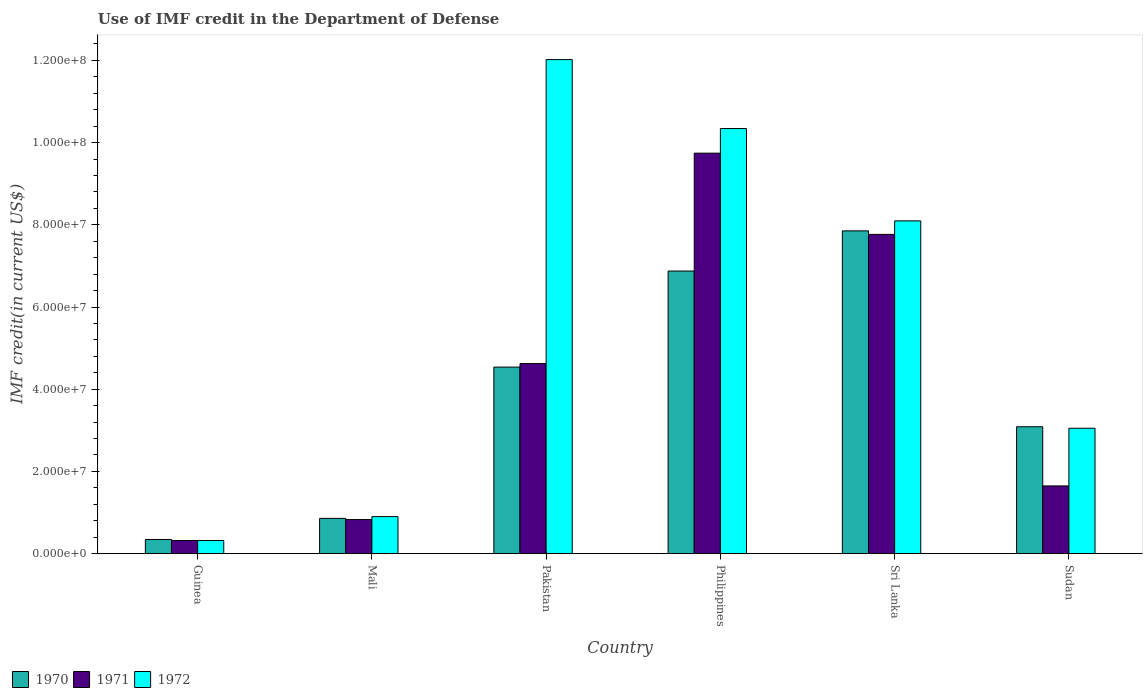How many bars are there on the 1st tick from the right?
Offer a terse response. 3. In how many cases, is the number of bars for a given country not equal to the number of legend labels?
Your answer should be very brief. 0. What is the IMF credit in the Department of Defense in 1972 in Philippines?
Your answer should be compact. 1.03e+08. Across all countries, what is the maximum IMF credit in the Department of Defense in 1971?
Your response must be concise. 9.74e+07. Across all countries, what is the minimum IMF credit in the Department of Defense in 1972?
Offer a very short reply. 3.20e+06. In which country was the IMF credit in the Department of Defense in 1971 minimum?
Provide a succinct answer. Guinea. What is the total IMF credit in the Department of Defense in 1972 in the graph?
Offer a very short reply. 3.47e+08. What is the difference between the IMF credit in the Department of Defense in 1971 in Sri Lanka and that in Sudan?
Offer a terse response. 6.12e+07. What is the difference between the IMF credit in the Department of Defense in 1972 in Sudan and the IMF credit in the Department of Defense in 1971 in Guinea?
Provide a short and direct response. 2.73e+07. What is the average IMF credit in the Department of Defense in 1972 per country?
Keep it short and to the point. 5.79e+07. What is the difference between the IMF credit in the Department of Defense of/in 1970 and IMF credit in the Department of Defense of/in 1972 in Philippines?
Your response must be concise. -3.47e+07. What is the ratio of the IMF credit in the Department of Defense in 1970 in Guinea to that in Sudan?
Your response must be concise. 0.11. What is the difference between the highest and the second highest IMF credit in the Department of Defense in 1971?
Your answer should be very brief. 1.98e+07. What is the difference between the highest and the lowest IMF credit in the Department of Defense in 1970?
Give a very brief answer. 7.51e+07. In how many countries, is the IMF credit in the Department of Defense in 1970 greater than the average IMF credit in the Department of Defense in 1970 taken over all countries?
Provide a short and direct response. 3. Is the sum of the IMF credit in the Department of Defense in 1972 in Sri Lanka and Sudan greater than the maximum IMF credit in the Department of Defense in 1970 across all countries?
Provide a succinct answer. Yes. What does the 2nd bar from the left in Mali represents?
Keep it short and to the point. 1971. How many countries are there in the graph?
Provide a succinct answer. 6. Does the graph contain any zero values?
Make the answer very short. No. Where does the legend appear in the graph?
Provide a short and direct response. Bottom left. How are the legend labels stacked?
Offer a terse response. Horizontal. What is the title of the graph?
Offer a very short reply. Use of IMF credit in the Department of Defense. Does "1985" appear as one of the legend labels in the graph?
Your answer should be very brief. No. What is the label or title of the Y-axis?
Provide a short and direct response. IMF credit(in current US$). What is the IMF credit(in current US$) of 1970 in Guinea?
Your answer should be compact. 3.45e+06. What is the IMF credit(in current US$) in 1971 in Guinea?
Keep it short and to the point. 3.20e+06. What is the IMF credit(in current US$) in 1972 in Guinea?
Your answer should be compact. 3.20e+06. What is the IMF credit(in current US$) of 1970 in Mali?
Provide a succinct answer. 8.58e+06. What is the IMF credit(in current US$) of 1971 in Mali?
Provide a succinct answer. 8.30e+06. What is the IMF credit(in current US$) of 1972 in Mali?
Provide a short and direct response. 9.01e+06. What is the IMF credit(in current US$) of 1970 in Pakistan?
Offer a terse response. 4.54e+07. What is the IMF credit(in current US$) of 1971 in Pakistan?
Your answer should be very brief. 4.62e+07. What is the IMF credit(in current US$) of 1972 in Pakistan?
Provide a short and direct response. 1.20e+08. What is the IMF credit(in current US$) of 1970 in Philippines?
Make the answer very short. 6.88e+07. What is the IMF credit(in current US$) of 1971 in Philippines?
Keep it short and to the point. 9.74e+07. What is the IMF credit(in current US$) of 1972 in Philippines?
Keep it short and to the point. 1.03e+08. What is the IMF credit(in current US$) in 1970 in Sri Lanka?
Your answer should be very brief. 7.85e+07. What is the IMF credit(in current US$) of 1971 in Sri Lanka?
Offer a very short reply. 7.77e+07. What is the IMF credit(in current US$) of 1972 in Sri Lanka?
Your answer should be very brief. 8.10e+07. What is the IMF credit(in current US$) in 1970 in Sudan?
Give a very brief answer. 3.09e+07. What is the IMF credit(in current US$) of 1971 in Sudan?
Your response must be concise. 1.65e+07. What is the IMF credit(in current US$) in 1972 in Sudan?
Provide a short and direct response. 3.05e+07. Across all countries, what is the maximum IMF credit(in current US$) of 1970?
Your response must be concise. 7.85e+07. Across all countries, what is the maximum IMF credit(in current US$) of 1971?
Offer a very short reply. 9.74e+07. Across all countries, what is the maximum IMF credit(in current US$) of 1972?
Provide a short and direct response. 1.20e+08. Across all countries, what is the minimum IMF credit(in current US$) of 1970?
Provide a short and direct response. 3.45e+06. Across all countries, what is the minimum IMF credit(in current US$) of 1971?
Provide a succinct answer. 3.20e+06. Across all countries, what is the minimum IMF credit(in current US$) in 1972?
Offer a terse response. 3.20e+06. What is the total IMF credit(in current US$) in 1970 in the graph?
Provide a short and direct response. 2.36e+08. What is the total IMF credit(in current US$) in 1971 in the graph?
Provide a succinct answer. 2.49e+08. What is the total IMF credit(in current US$) of 1972 in the graph?
Offer a terse response. 3.47e+08. What is the difference between the IMF credit(in current US$) in 1970 in Guinea and that in Mali?
Provide a succinct answer. -5.13e+06. What is the difference between the IMF credit(in current US$) in 1971 in Guinea and that in Mali?
Your answer should be compact. -5.09e+06. What is the difference between the IMF credit(in current US$) in 1972 in Guinea and that in Mali?
Make the answer very short. -5.81e+06. What is the difference between the IMF credit(in current US$) in 1970 in Guinea and that in Pakistan?
Your response must be concise. -4.19e+07. What is the difference between the IMF credit(in current US$) in 1971 in Guinea and that in Pakistan?
Keep it short and to the point. -4.30e+07. What is the difference between the IMF credit(in current US$) in 1972 in Guinea and that in Pakistan?
Your response must be concise. -1.17e+08. What is the difference between the IMF credit(in current US$) in 1970 in Guinea and that in Philippines?
Give a very brief answer. -6.53e+07. What is the difference between the IMF credit(in current US$) of 1971 in Guinea and that in Philippines?
Keep it short and to the point. -9.42e+07. What is the difference between the IMF credit(in current US$) of 1972 in Guinea and that in Philippines?
Make the answer very short. -1.00e+08. What is the difference between the IMF credit(in current US$) in 1970 in Guinea and that in Sri Lanka?
Give a very brief answer. -7.51e+07. What is the difference between the IMF credit(in current US$) of 1971 in Guinea and that in Sri Lanka?
Your response must be concise. -7.45e+07. What is the difference between the IMF credit(in current US$) of 1972 in Guinea and that in Sri Lanka?
Your response must be concise. -7.77e+07. What is the difference between the IMF credit(in current US$) in 1970 in Guinea and that in Sudan?
Provide a short and direct response. -2.74e+07. What is the difference between the IMF credit(in current US$) of 1971 in Guinea and that in Sudan?
Give a very brief answer. -1.33e+07. What is the difference between the IMF credit(in current US$) in 1972 in Guinea and that in Sudan?
Provide a short and direct response. -2.73e+07. What is the difference between the IMF credit(in current US$) of 1970 in Mali and that in Pakistan?
Your response must be concise. -3.68e+07. What is the difference between the IMF credit(in current US$) of 1971 in Mali and that in Pakistan?
Provide a short and direct response. -3.79e+07. What is the difference between the IMF credit(in current US$) of 1972 in Mali and that in Pakistan?
Offer a very short reply. -1.11e+08. What is the difference between the IMF credit(in current US$) of 1970 in Mali and that in Philippines?
Offer a terse response. -6.02e+07. What is the difference between the IMF credit(in current US$) in 1971 in Mali and that in Philippines?
Make the answer very short. -8.91e+07. What is the difference between the IMF credit(in current US$) in 1972 in Mali and that in Philippines?
Offer a very short reply. -9.44e+07. What is the difference between the IMF credit(in current US$) in 1970 in Mali and that in Sri Lanka?
Your answer should be compact. -6.99e+07. What is the difference between the IMF credit(in current US$) in 1971 in Mali and that in Sri Lanka?
Keep it short and to the point. -6.94e+07. What is the difference between the IMF credit(in current US$) in 1972 in Mali and that in Sri Lanka?
Ensure brevity in your answer.  -7.19e+07. What is the difference between the IMF credit(in current US$) of 1970 in Mali and that in Sudan?
Offer a terse response. -2.23e+07. What is the difference between the IMF credit(in current US$) of 1971 in Mali and that in Sudan?
Ensure brevity in your answer.  -8.19e+06. What is the difference between the IMF credit(in current US$) in 1972 in Mali and that in Sudan?
Your response must be concise. -2.15e+07. What is the difference between the IMF credit(in current US$) of 1970 in Pakistan and that in Philippines?
Provide a short and direct response. -2.34e+07. What is the difference between the IMF credit(in current US$) of 1971 in Pakistan and that in Philippines?
Offer a terse response. -5.12e+07. What is the difference between the IMF credit(in current US$) of 1972 in Pakistan and that in Philippines?
Your response must be concise. 1.68e+07. What is the difference between the IMF credit(in current US$) of 1970 in Pakistan and that in Sri Lanka?
Offer a terse response. -3.31e+07. What is the difference between the IMF credit(in current US$) of 1971 in Pakistan and that in Sri Lanka?
Your answer should be very brief. -3.14e+07. What is the difference between the IMF credit(in current US$) in 1972 in Pakistan and that in Sri Lanka?
Your answer should be compact. 3.92e+07. What is the difference between the IMF credit(in current US$) in 1970 in Pakistan and that in Sudan?
Offer a very short reply. 1.45e+07. What is the difference between the IMF credit(in current US$) in 1971 in Pakistan and that in Sudan?
Make the answer very short. 2.98e+07. What is the difference between the IMF credit(in current US$) of 1972 in Pakistan and that in Sudan?
Provide a succinct answer. 8.97e+07. What is the difference between the IMF credit(in current US$) in 1970 in Philippines and that in Sri Lanka?
Make the answer very short. -9.77e+06. What is the difference between the IMF credit(in current US$) of 1971 in Philippines and that in Sri Lanka?
Provide a short and direct response. 1.98e+07. What is the difference between the IMF credit(in current US$) in 1972 in Philippines and that in Sri Lanka?
Your answer should be very brief. 2.25e+07. What is the difference between the IMF credit(in current US$) of 1970 in Philippines and that in Sudan?
Make the answer very short. 3.79e+07. What is the difference between the IMF credit(in current US$) of 1971 in Philippines and that in Sudan?
Make the answer very short. 8.09e+07. What is the difference between the IMF credit(in current US$) in 1972 in Philippines and that in Sudan?
Your answer should be very brief. 7.29e+07. What is the difference between the IMF credit(in current US$) in 1970 in Sri Lanka and that in Sudan?
Your answer should be very brief. 4.76e+07. What is the difference between the IMF credit(in current US$) of 1971 in Sri Lanka and that in Sudan?
Keep it short and to the point. 6.12e+07. What is the difference between the IMF credit(in current US$) of 1972 in Sri Lanka and that in Sudan?
Offer a terse response. 5.04e+07. What is the difference between the IMF credit(in current US$) of 1970 in Guinea and the IMF credit(in current US$) of 1971 in Mali?
Offer a very short reply. -4.84e+06. What is the difference between the IMF credit(in current US$) of 1970 in Guinea and the IMF credit(in current US$) of 1972 in Mali?
Offer a terse response. -5.56e+06. What is the difference between the IMF credit(in current US$) of 1971 in Guinea and the IMF credit(in current US$) of 1972 in Mali?
Your answer should be compact. -5.81e+06. What is the difference between the IMF credit(in current US$) of 1970 in Guinea and the IMF credit(in current US$) of 1971 in Pakistan?
Offer a very short reply. -4.28e+07. What is the difference between the IMF credit(in current US$) of 1970 in Guinea and the IMF credit(in current US$) of 1972 in Pakistan?
Provide a succinct answer. -1.17e+08. What is the difference between the IMF credit(in current US$) of 1971 in Guinea and the IMF credit(in current US$) of 1972 in Pakistan?
Your answer should be very brief. -1.17e+08. What is the difference between the IMF credit(in current US$) of 1970 in Guinea and the IMF credit(in current US$) of 1971 in Philippines?
Make the answer very short. -9.40e+07. What is the difference between the IMF credit(in current US$) of 1970 in Guinea and the IMF credit(in current US$) of 1972 in Philippines?
Offer a terse response. -1.00e+08. What is the difference between the IMF credit(in current US$) in 1971 in Guinea and the IMF credit(in current US$) in 1972 in Philippines?
Your answer should be very brief. -1.00e+08. What is the difference between the IMF credit(in current US$) in 1970 in Guinea and the IMF credit(in current US$) in 1971 in Sri Lanka?
Give a very brief answer. -7.42e+07. What is the difference between the IMF credit(in current US$) in 1970 in Guinea and the IMF credit(in current US$) in 1972 in Sri Lanka?
Ensure brevity in your answer.  -7.75e+07. What is the difference between the IMF credit(in current US$) of 1971 in Guinea and the IMF credit(in current US$) of 1972 in Sri Lanka?
Give a very brief answer. -7.77e+07. What is the difference between the IMF credit(in current US$) in 1970 in Guinea and the IMF credit(in current US$) in 1971 in Sudan?
Give a very brief answer. -1.30e+07. What is the difference between the IMF credit(in current US$) in 1970 in Guinea and the IMF credit(in current US$) in 1972 in Sudan?
Ensure brevity in your answer.  -2.71e+07. What is the difference between the IMF credit(in current US$) in 1971 in Guinea and the IMF credit(in current US$) in 1972 in Sudan?
Your answer should be very brief. -2.73e+07. What is the difference between the IMF credit(in current US$) in 1970 in Mali and the IMF credit(in current US$) in 1971 in Pakistan?
Your response must be concise. -3.77e+07. What is the difference between the IMF credit(in current US$) in 1970 in Mali and the IMF credit(in current US$) in 1972 in Pakistan?
Your response must be concise. -1.12e+08. What is the difference between the IMF credit(in current US$) of 1971 in Mali and the IMF credit(in current US$) of 1972 in Pakistan?
Provide a succinct answer. -1.12e+08. What is the difference between the IMF credit(in current US$) of 1970 in Mali and the IMF credit(in current US$) of 1971 in Philippines?
Your answer should be very brief. -8.88e+07. What is the difference between the IMF credit(in current US$) of 1970 in Mali and the IMF credit(in current US$) of 1972 in Philippines?
Keep it short and to the point. -9.48e+07. What is the difference between the IMF credit(in current US$) in 1971 in Mali and the IMF credit(in current US$) in 1972 in Philippines?
Your answer should be very brief. -9.51e+07. What is the difference between the IMF credit(in current US$) of 1970 in Mali and the IMF credit(in current US$) of 1971 in Sri Lanka?
Keep it short and to the point. -6.91e+07. What is the difference between the IMF credit(in current US$) in 1970 in Mali and the IMF credit(in current US$) in 1972 in Sri Lanka?
Provide a succinct answer. -7.24e+07. What is the difference between the IMF credit(in current US$) in 1971 in Mali and the IMF credit(in current US$) in 1972 in Sri Lanka?
Make the answer very short. -7.27e+07. What is the difference between the IMF credit(in current US$) of 1970 in Mali and the IMF credit(in current US$) of 1971 in Sudan?
Make the answer very short. -7.90e+06. What is the difference between the IMF credit(in current US$) of 1970 in Mali and the IMF credit(in current US$) of 1972 in Sudan?
Make the answer very short. -2.19e+07. What is the difference between the IMF credit(in current US$) of 1971 in Mali and the IMF credit(in current US$) of 1972 in Sudan?
Keep it short and to the point. -2.22e+07. What is the difference between the IMF credit(in current US$) of 1970 in Pakistan and the IMF credit(in current US$) of 1971 in Philippines?
Give a very brief answer. -5.20e+07. What is the difference between the IMF credit(in current US$) in 1970 in Pakistan and the IMF credit(in current US$) in 1972 in Philippines?
Keep it short and to the point. -5.80e+07. What is the difference between the IMF credit(in current US$) in 1971 in Pakistan and the IMF credit(in current US$) in 1972 in Philippines?
Your response must be concise. -5.72e+07. What is the difference between the IMF credit(in current US$) in 1970 in Pakistan and the IMF credit(in current US$) in 1971 in Sri Lanka?
Make the answer very short. -3.23e+07. What is the difference between the IMF credit(in current US$) in 1970 in Pakistan and the IMF credit(in current US$) in 1972 in Sri Lanka?
Offer a terse response. -3.56e+07. What is the difference between the IMF credit(in current US$) in 1971 in Pakistan and the IMF credit(in current US$) in 1972 in Sri Lanka?
Provide a succinct answer. -3.47e+07. What is the difference between the IMF credit(in current US$) of 1970 in Pakistan and the IMF credit(in current US$) of 1971 in Sudan?
Offer a very short reply. 2.89e+07. What is the difference between the IMF credit(in current US$) of 1970 in Pakistan and the IMF credit(in current US$) of 1972 in Sudan?
Your answer should be very brief. 1.49e+07. What is the difference between the IMF credit(in current US$) of 1971 in Pakistan and the IMF credit(in current US$) of 1972 in Sudan?
Your answer should be very brief. 1.57e+07. What is the difference between the IMF credit(in current US$) in 1970 in Philippines and the IMF credit(in current US$) in 1971 in Sri Lanka?
Offer a very short reply. -8.91e+06. What is the difference between the IMF credit(in current US$) in 1970 in Philippines and the IMF credit(in current US$) in 1972 in Sri Lanka?
Provide a short and direct response. -1.22e+07. What is the difference between the IMF credit(in current US$) of 1971 in Philippines and the IMF credit(in current US$) of 1972 in Sri Lanka?
Offer a very short reply. 1.65e+07. What is the difference between the IMF credit(in current US$) in 1970 in Philippines and the IMF credit(in current US$) in 1971 in Sudan?
Give a very brief answer. 5.23e+07. What is the difference between the IMF credit(in current US$) of 1970 in Philippines and the IMF credit(in current US$) of 1972 in Sudan?
Give a very brief answer. 3.82e+07. What is the difference between the IMF credit(in current US$) of 1971 in Philippines and the IMF credit(in current US$) of 1972 in Sudan?
Your answer should be compact. 6.69e+07. What is the difference between the IMF credit(in current US$) in 1970 in Sri Lanka and the IMF credit(in current US$) in 1971 in Sudan?
Make the answer very short. 6.20e+07. What is the difference between the IMF credit(in current US$) of 1970 in Sri Lanka and the IMF credit(in current US$) of 1972 in Sudan?
Provide a succinct answer. 4.80e+07. What is the difference between the IMF credit(in current US$) of 1971 in Sri Lanka and the IMF credit(in current US$) of 1972 in Sudan?
Your answer should be very brief. 4.72e+07. What is the average IMF credit(in current US$) in 1970 per country?
Keep it short and to the point. 3.93e+07. What is the average IMF credit(in current US$) of 1971 per country?
Offer a very short reply. 4.16e+07. What is the average IMF credit(in current US$) of 1972 per country?
Give a very brief answer. 5.79e+07. What is the difference between the IMF credit(in current US$) of 1970 and IMF credit(in current US$) of 1971 in Guinea?
Keep it short and to the point. 2.47e+05. What is the difference between the IMF credit(in current US$) of 1970 and IMF credit(in current US$) of 1972 in Guinea?
Ensure brevity in your answer.  2.47e+05. What is the difference between the IMF credit(in current US$) of 1971 and IMF credit(in current US$) of 1972 in Guinea?
Provide a succinct answer. 0. What is the difference between the IMF credit(in current US$) of 1970 and IMF credit(in current US$) of 1971 in Mali?
Your answer should be very brief. 2.85e+05. What is the difference between the IMF credit(in current US$) in 1970 and IMF credit(in current US$) in 1972 in Mali?
Offer a very short reply. -4.31e+05. What is the difference between the IMF credit(in current US$) in 1971 and IMF credit(in current US$) in 1972 in Mali?
Your response must be concise. -7.16e+05. What is the difference between the IMF credit(in current US$) in 1970 and IMF credit(in current US$) in 1971 in Pakistan?
Provide a succinct answer. -8.56e+05. What is the difference between the IMF credit(in current US$) of 1970 and IMF credit(in current US$) of 1972 in Pakistan?
Keep it short and to the point. -7.48e+07. What is the difference between the IMF credit(in current US$) in 1971 and IMF credit(in current US$) in 1972 in Pakistan?
Your answer should be compact. -7.40e+07. What is the difference between the IMF credit(in current US$) in 1970 and IMF credit(in current US$) in 1971 in Philippines?
Your response must be concise. -2.87e+07. What is the difference between the IMF credit(in current US$) in 1970 and IMF credit(in current US$) in 1972 in Philippines?
Your answer should be compact. -3.47e+07. What is the difference between the IMF credit(in current US$) in 1971 and IMF credit(in current US$) in 1972 in Philippines?
Offer a very short reply. -5.99e+06. What is the difference between the IMF credit(in current US$) of 1970 and IMF credit(in current US$) of 1971 in Sri Lanka?
Ensure brevity in your answer.  8.56e+05. What is the difference between the IMF credit(in current US$) in 1970 and IMF credit(in current US$) in 1972 in Sri Lanka?
Offer a very short reply. -2.43e+06. What is the difference between the IMF credit(in current US$) of 1971 and IMF credit(in current US$) of 1972 in Sri Lanka?
Your response must be concise. -3.29e+06. What is the difference between the IMF credit(in current US$) of 1970 and IMF credit(in current US$) of 1971 in Sudan?
Keep it short and to the point. 1.44e+07. What is the difference between the IMF credit(in current US$) of 1970 and IMF credit(in current US$) of 1972 in Sudan?
Your response must be concise. 3.62e+05. What is the difference between the IMF credit(in current US$) of 1971 and IMF credit(in current US$) of 1972 in Sudan?
Your answer should be compact. -1.40e+07. What is the ratio of the IMF credit(in current US$) in 1970 in Guinea to that in Mali?
Your response must be concise. 0.4. What is the ratio of the IMF credit(in current US$) in 1971 in Guinea to that in Mali?
Keep it short and to the point. 0.39. What is the ratio of the IMF credit(in current US$) of 1972 in Guinea to that in Mali?
Your response must be concise. 0.36. What is the ratio of the IMF credit(in current US$) of 1970 in Guinea to that in Pakistan?
Your answer should be compact. 0.08. What is the ratio of the IMF credit(in current US$) of 1971 in Guinea to that in Pakistan?
Your response must be concise. 0.07. What is the ratio of the IMF credit(in current US$) of 1972 in Guinea to that in Pakistan?
Ensure brevity in your answer.  0.03. What is the ratio of the IMF credit(in current US$) in 1970 in Guinea to that in Philippines?
Provide a short and direct response. 0.05. What is the ratio of the IMF credit(in current US$) in 1971 in Guinea to that in Philippines?
Ensure brevity in your answer.  0.03. What is the ratio of the IMF credit(in current US$) of 1972 in Guinea to that in Philippines?
Keep it short and to the point. 0.03. What is the ratio of the IMF credit(in current US$) of 1970 in Guinea to that in Sri Lanka?
Provide a succinct answer. 0.04. What is the ratio of the IMF credit(in current US$) of 1971 in Guinea to that in Sri Lanka?
Make the answer very short. 0.04. What is the ratio of the IMF credit(in current US$) in 1972 in Guinea to that in Sri Lanka?
Give a very brief answer. 0.04. What is the ratio of the IMF credit(in current US$) of 1970 in Guinea to that in Sudan?
Give a very brief answer. 0.11. What is the ratio of the IMF credit(in current US$) of 1971 in Guinea to that in Sudan?
Make the answer very short. 0.19. What is the ratio of the IMF credit(in current US$) of 1972 in Guinea to that in Sudan?
Your answer should be very brief. 0.1. What is the ratio of the IMF credit(in current US$) of 1970 in Mali to that in Pakistan?
Make the answer very short. 0.19. What is the ratio of the IMF credit(in current US$) of 1971 in Mali to that in Pakistan?
Your answer should be very brief. 0.18. What is the ratio of the IMF credit(in current US$) in 1972 in Mali to that in Pakistan?
Provide a succinct answer. 0.07. What is the ratio of the IMF credit(in current US$) in 1970 in Mali to that in Philippines?
Your response must be concise. 0.12. What is the ratio of the IMF credit(in current US$) of 1971 in Mali to that in Philippines?
Provide a short and direct response. 0.09. What is the ratio of the IMF credit(in current US$) in 1972 in Mali to that in Philippines?
Offer a terse response. 0.09. What is the ratio of the IMF credit(in current US$) of 1970 in Mali to that in Sri Lanka?
Provide a succinct answer. 0.11. What is the ratio of the IMF credit(in current US$) of 1971 in Mali to that in Sri Lanka?
Your response must be concise. 0.11. What is the ratio of the IMF credit(in current US$) of 1972 in Mali to that in Sri Lanka?
Your answer should be compact. 0.11. What is the ratio of the IMF credit(in current US$) of 1970 in Mali to that in Sudan?
Provide a succinct answer. 0.28. What is the ratio of the IMF credit(in current US$) of 1971 in Mali to that in Sudan?
Your response must be concise. 0.5. What is the ratio of the IMF credit(in current US$) of 1972 in Mali to that in Sudan?
Your response must be concise. 0.3. What is the ratio of the IMF credit(in current US$) of 1970 in Pakistan to that in Philippines?
Your answer should be compact. 0.66. What is the ratio of the IMF credit(in current US$) in 1971 in Pakistan to that in Philippines?
Make the answer very short. 0.47. What is the ratio of the IMF credit(in current US$) of 1972 in Pakistan to that in Philippines?
Ensure brevity in your answer.  1.16. What is the ratio of the IMF credit(in current US$) in 1970 in Pakistan to that in Sri Lanka?
Offer a very short reply. 0.58. What is the ratio of the IMF credit(in current US$) of 1971 in Pakistan to that in Sri Lanka?
Your answer should be very brief. 0.6. What is the ratio of the IMF credit(in current US$) in 1972 in Pakistan to that in Sri Lanka?
Ensure brevity in your answer.  1.48. What is the ratio of the IMF credit(in current US$) of 1970 in Pakistan to that in Sudan?
Provide a short and direct response. 1.47. What is the ratio of the IMF credit(in current US$) in 1971 in Pakistan to that in Sudan?
Your answer should be very brief. 2.81. What is the ratio of the IMF credit(in current US$) of 1972 in Pakistan to that in Sudan?
Ensure brevity in your answer.  3.94. What is the ratio of the IMF credit(in current US$) of 1970 in Philippines to that in Sri Lanka?
Offer a terse response. 0.88. What is the ratio of the IMF credit(in current US$) of 1971 in Philippines to that in Sri Lanka?
Ensure brevity in your answer.  1.25. What is the ratio of the IMF credit(in current US$) of 1972 in Philippines to that in Sri Lanka?
Offer a terse response. 1.28. What is the ratio of the IMF credit(in current US$) in 1970 in Philippines to that in Sudan?
Offer a terse response. 2.23. What is the ratio of the IMF credit(in current US$) of 1971 in Philippines to that in Sudan?
Make the answer very short. 5.91. What is the ratio of the IMF credit(in current US$) of 1972 in Philippines to that in Sudan?
Provide a succinct answer. 3.39. What is the ratio of the IMF credit(in current US$) in 1970 in Sri Lanka to that in Sudan?
Your answer should be compact. 2.54. What is the ratio of the IMF credit(in current US$) of 1971 in Sri Lanka to that in Sudan?
Your answer should be compact. 4.71. What is the ratio of the IMF credit(in current US$) in 1972 in Sri Lanka to that in Sudan?
Offer a terse response. 2.65. What is the difference between the highest and the second highest IMF credit(in current US$) of 1970?
Provide a succinct answer. 9.77e+06. What is the difference between the highest and the second highest IMF credit(in current US$) of 1971?
Your answer should be compact. 1.98e+07. What is the difference between the highest and the second highest IMF credit(in current US$) in 1972?
Make the answer very short. 1.68e+07. What is the difference between the highest and the lowest IMF credit(in current US$) of 1970?
Your answer should be very brief. 7.51e+07. What is the difference between the highest and the lowest IMF credit(in current US$) in 1971?
Offer a very short reply. 9.42e+07. What is the difference between the highest and the lowest IMF credit(in current US$) in 1972?
Make the answer very short. 1.17e+08. 